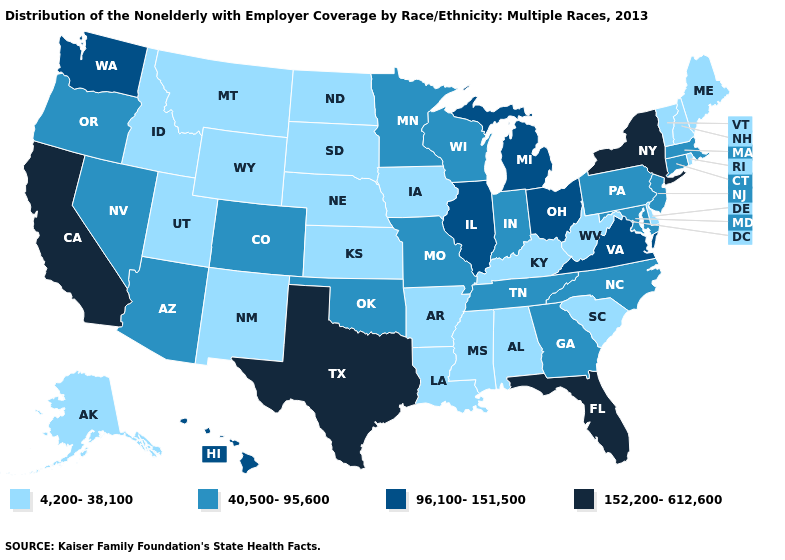What is the value of Vermont?
Be succinct. 4,200-38,100. What is the value of Tennessee?
Short answer required. 40,500-95,600. Name the states that have a value in the range 96,100-151,500?
Give a very brief answer. Hawaii, Illinois, Michigan, Ohio, Virginia, Washington. Name the states that have a value in the range 40,500-95,600?
Keep it brief. Arizona, Colorado, Connecticut, Georgia, Indiana, Maryland, Massachusetts, Minnesota, Missouri, Nevada, New Jersey, North Carolina, Oklahoma, Oregon, Pennsylvania, Tennessee, Wisconsin. What is the highest value in the USA?
Short answer required. 152,200-612,600. Among the states that border Florida , does Georgia have the highest value?
Quick response, please. Yes. Which states have the highest value in the USA?
Answer briefly. California, Florida, New York, Texas. What is the lowest value in the Northeast?
Concise answer only. 4,200-38,100. Does Colorado have the highest value in the West?
Give a very brief answer. No. Name the states that have a value in the range 152,200-612,600?
Write a very short answer. California, Florida, New York, Texas. Name the states that have a value in the range 96,100-151,500?
Write a very short answer. Hawaii, Illinois, Michigan, Ohio, Virginia, Washington. Which states have the lowest value in the USA?
Quick response, please. Alabama, Alaska, Arkansas, Delaware, Idaho, Iowa, Kansas, Kentucky, Louisiana, Maine, Mississippi, Montana, Nebraska, New Hampshire, New Mexico, North Dakota, Rhode Island, South Carolina, South Dakota, Utah, Vermont, West Virginia, Wyoming. What is the value of New Jersey?
Answer briefly. 40,500-95,600. Name the states that have a value in the range 96,100-151,500?
Answer briefly. Hawaii, Illinois, Michigan, Ohio, Virginia, Washington. What is the highest value in the USA?
Concise answer only. 152,200-612,600. 